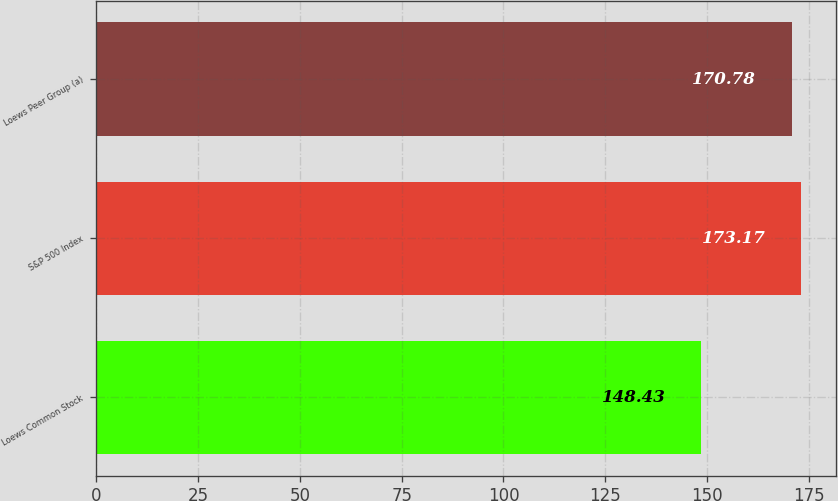<chart> <loc_0><loc_0><loc_500><loc_500><bar_chart><fcel>Loews Common Stock<fcel>S&P 500 Index<fcel>Loews Peer Group (a)<nl><fcel>148.43<fcel>173.17<fcel>170.78<nl></chart> 